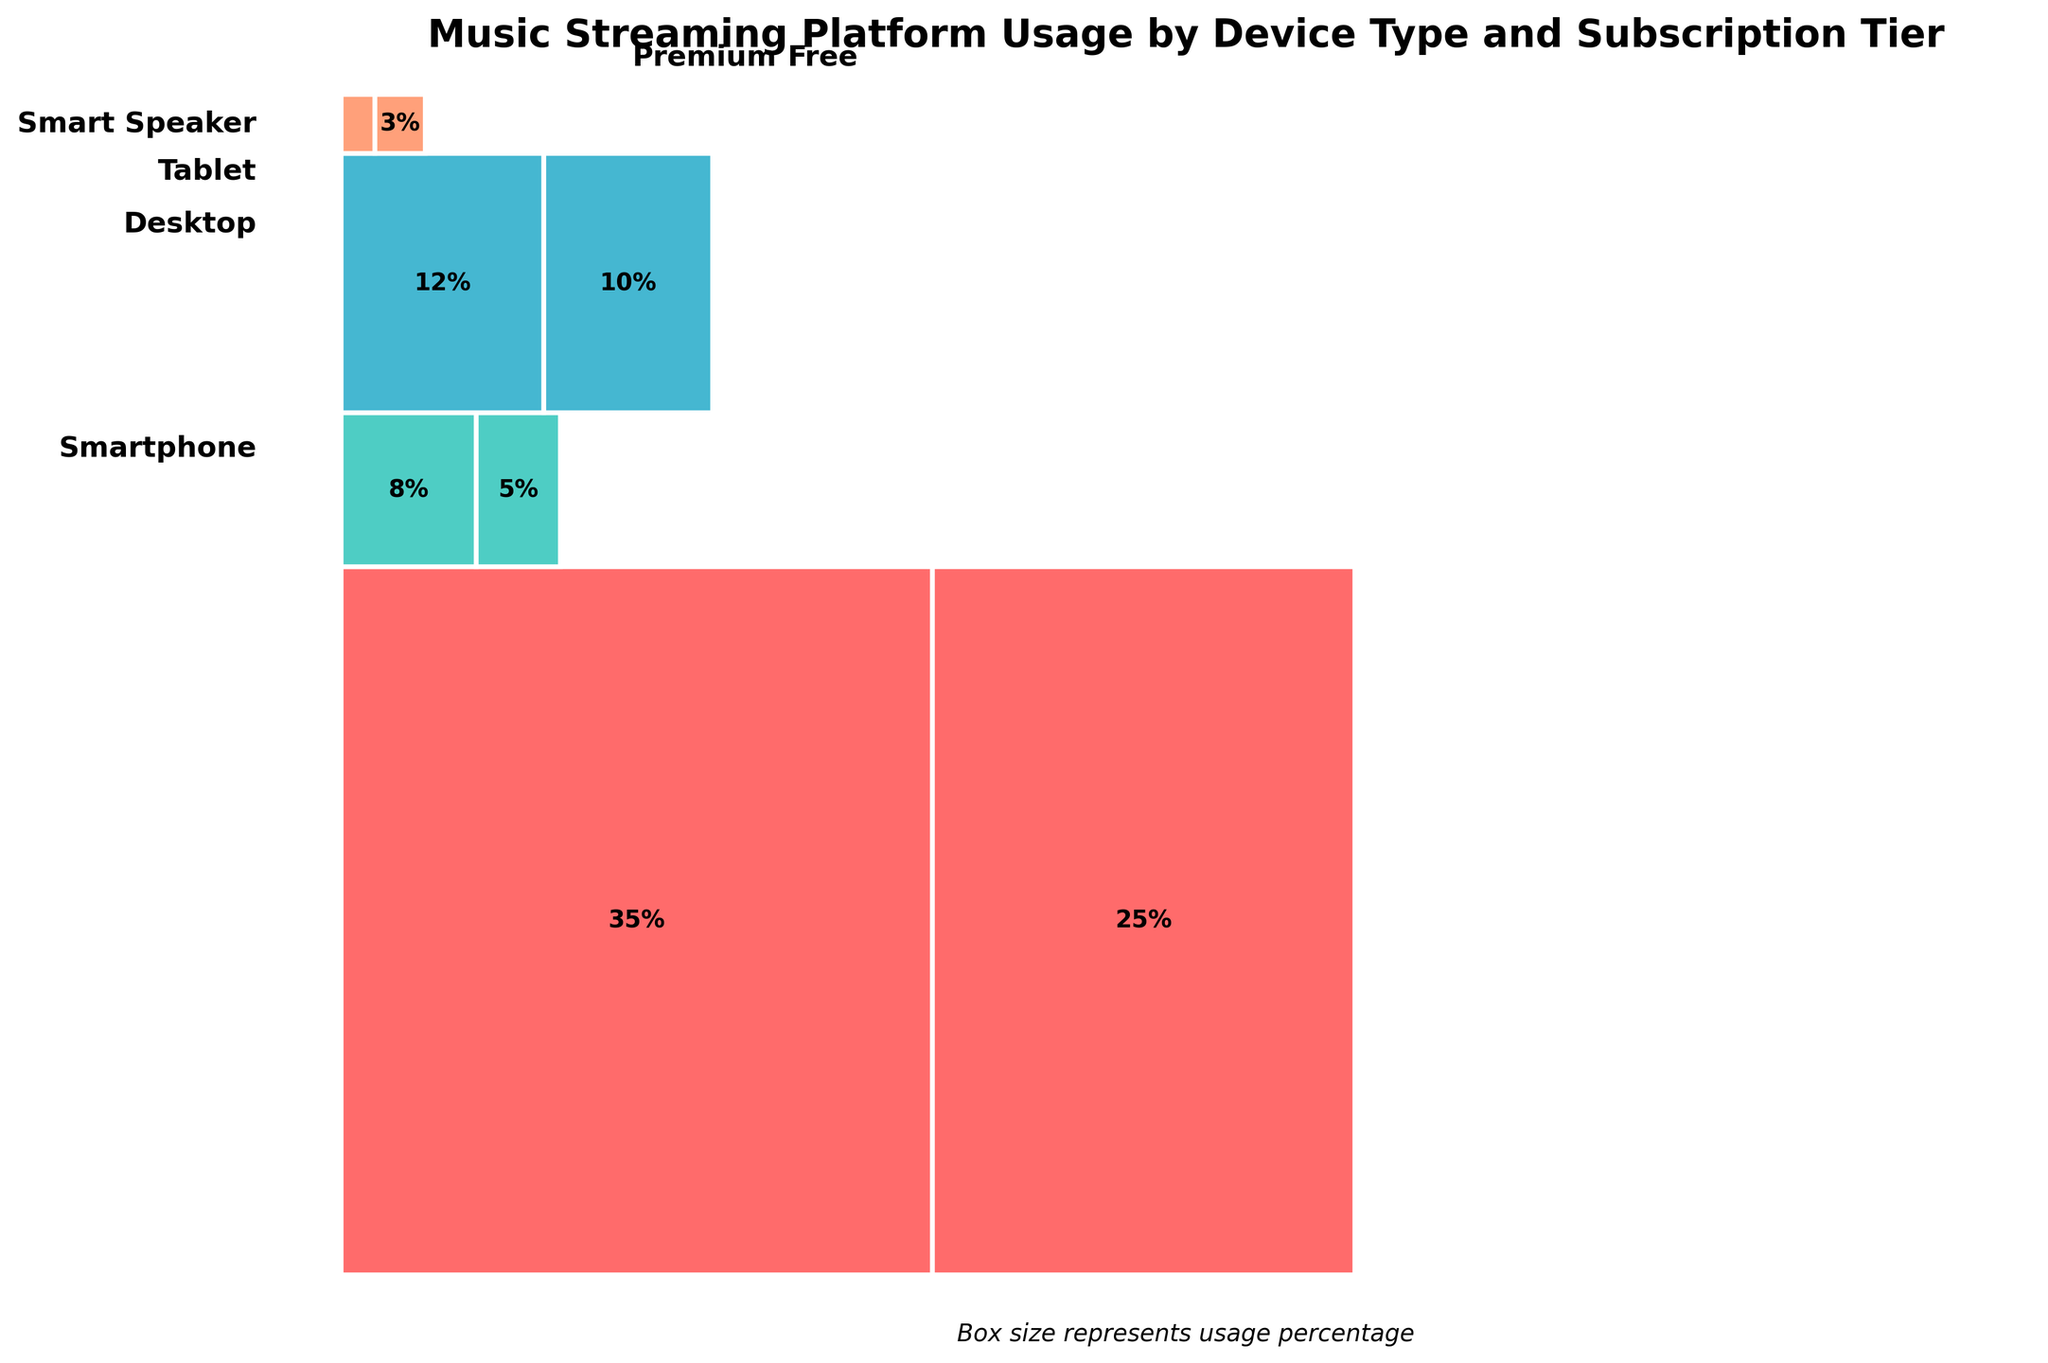How many device types are represented in the figure? By observing the figure, look for distinct categories listed on the y-axis which each represent different device types. Count these categories. There are four device types: Smartphone, Tablet, Desktop, and Smart Speaker.
Answer: 4 Which subscription tier has the highest overall usage percentage across all devices? Add the usage percentages for each subscription tier across all devices. Free: 35 + 8 + 12 + 2 = 57%, Premium: 25 + 5 + 10 + 3 = 43%. The Free tier has the highest overall usage percentage.
Answer: Free What is the total usage percentage for Tablets? Add the usage percentages of both subscription tiers for Tablets. Tablet Free: 8%, Tablet Premium: 5%. Total: 8 + 5 = 13%.
Answer: 13% Which subscription tier is used more on Desktops? Identify the usage percentages of the Free and Premium tiers on Desktops from the figure. Compare 12% (Free) with 10% (Premium). The Free tier is used more on Desktops.
Answer: Free For Smart Speakers, does the Premium tier usage exceed that of the Free tier? Observe the usage percentages for both tiers on Smart Speakers. Free tier: 2%, Premium tier: 3%. The Premium tier usage exceeds the Free tier.
Answer: Yes Which device type shows the smallest difference in usage percentage between Free and Premium tiers? Calculate the difference between Free and Premium usage for each device type: Smartphone (35 - 25 = 10%), Tablet (8 - 5 = 3%), Desktop (12 - 10 = 2%), Smart Speaker (2 - 3 = 1%). The device type with the smallest difference is the Smart Speaker.
Answer: Smart Speaker Are Premium users more likely to use Desktops or Tablets? Compare the usage percentages for Premium users on Desktops and Tablets. Desktop Premium: 10%, Tablet Premium: 5%. Premium users are more likely to use Desktops.
Answer: Desktops Which device type and subscription tier combination represents the lowest usage percentage? Identify the smallest rectangle in the figure. The combination representing the lowest usage percentage is Smart Speaker Free with 2%.
Answer: Smart Speaker Free What's the total percentage usage for smartphones? Sum the Free and Premium usage percentages for Smartphones. Smartphone Free: 35%, Smartphone Premium: 25%. Total: 35 + 25 = 60%.
Answer: 60% In terms of subscription tiers, which device type has the highest variation in usage? Calculate the variation by subtracting the Free and Premium usage percentages for each device type: Smartphone (35 - 25 = 10%), Tablet (8 - 5 = 3%), Desktop (12 - 10 = 2%), Smart Speaker (2 - 3 = 1%). The highest variation is seen in Smartphones at 10%.
Answer: Smartphone 